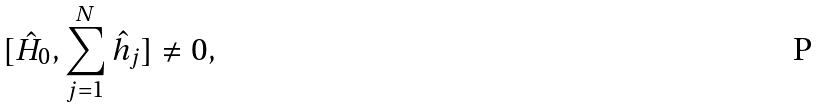<formula> <loc_0><loc_0><loc_500><loc_500>[ \hat { H } _ { 0 } , \sum _ { j = 1 } ^ { N } \hat { h } _ { j } ] \ne 0 ,</formula> 